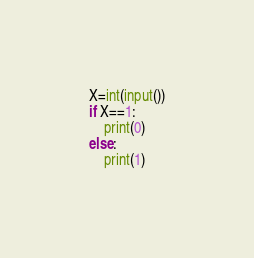Convert code to text. <code><loc_0><loc_0><loc_500><loc_500><_Python_>X=int(input())
if X==1:
    print(0)
else:
    print(1)</code> 